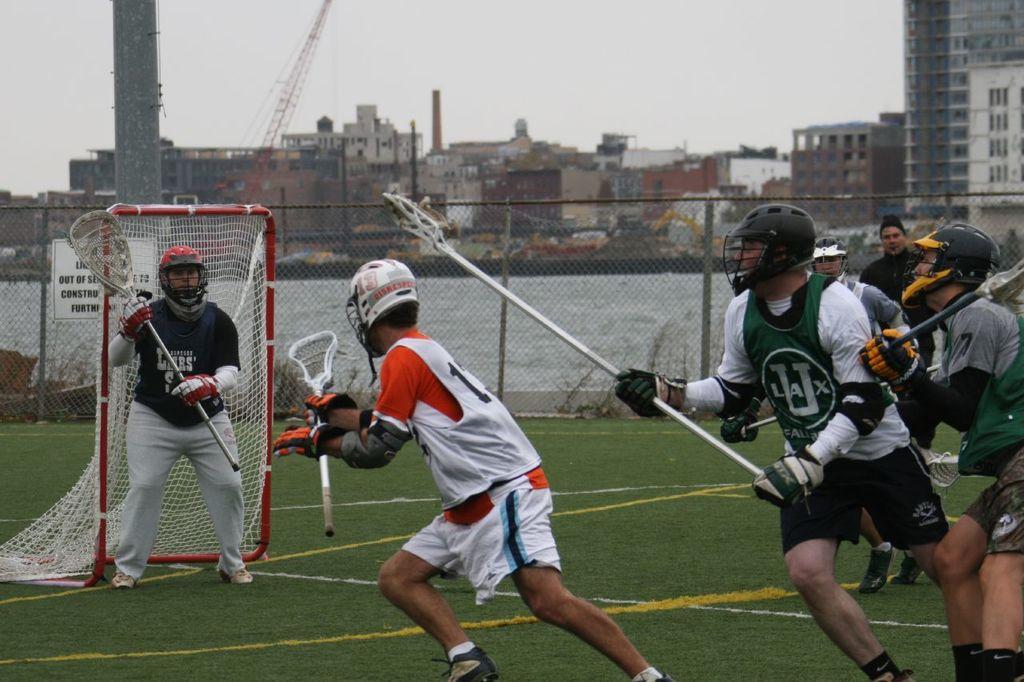Which team is in green?
Your response must be concise. Ulax. 